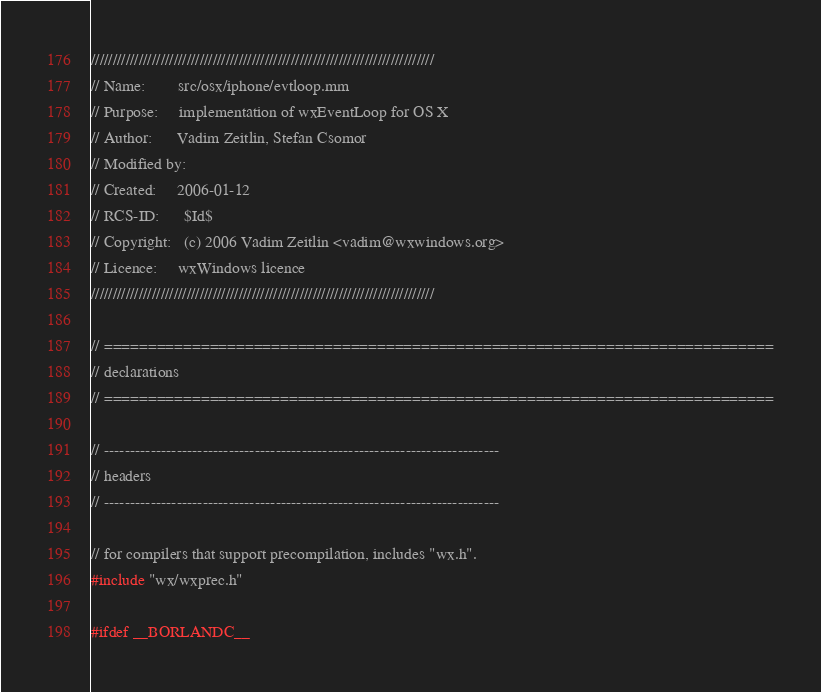<code> <loc_0><loc_0><loc_500><loc_500><_ObjectiveC_>///////////////////////////////////////////////////////////////////////////////
// Name:        src/osx/iphone/evtloop.mm
// Purpose:     implementation of wxEventLoop for OS X
// Author:      Vadim Zeitlin, Stefan Csomor
// Modified by:
// Created:     2006-01-12
// RCS-ID:      $Id$
// Copyright:   (c) 2006 Vadim Zeitlin <vadim@wxwindows.org>
// Licence:     wxWindows licence
///////////////////////////////////////////////////////////////////////////////

// ============================================================================
// declarations
// ============================================================================

// ----------------------------------------------------------------------------
// headers
// ----------------------------------------------------------------------------

// for compilers that support precompilation, includes "wx.h".
#include "wx/wxprec.h"

#ifdef __BORLANDC__</code> 